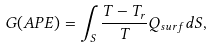<formula> <loc_0><loc_0><loc_500><loc_500>G ( A P E ) = \int _ { S } \frac { T - T _ { r } } { T } Q _ { s u r f } d S ,</formula> 